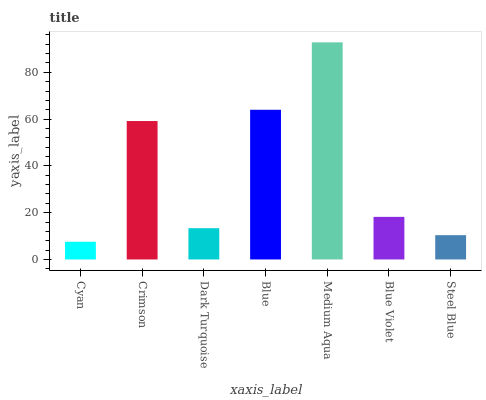Is Cyan the minimum?
Answer yes or no. Yes. Is Medium Aqua the maximum?
Answer yes or no. Yes. Is Crimson the minimum?
Answer yes or no. No. Is Crimson the maximum?
Answer yes or no. No. Is Crimson greater than Cyan?
Answer yes or no. Yes. Is Cyan less than Crimson?
Answer yes or no. Yes. Is Cyan greater than Crimson?
Answer yes or no. No. Is Crimson less than Cyan?
Answer yes or no. No. Is Blue Violet the high median?
Answer yes or no. Yes. Is Blue Violet the low median?
Answer yes or no. Yes. Is Cyan the high median?
Answer yes or no. No. Is Crimson the low median?
Answer yes or no. No. 